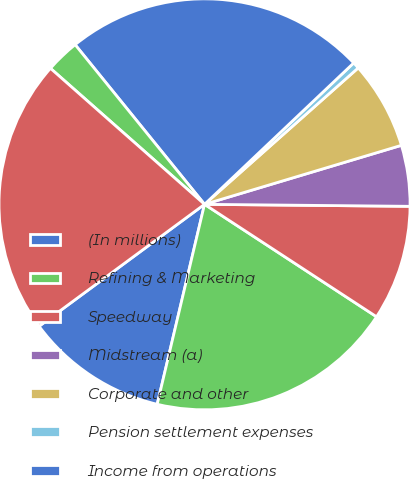Convert chart to OTSL. <chart><loc_0><loc_0><loc_500><loc_500><pie_chart><fcel>(In millions)<fcel>Refining & Marketing<fcel>Speedway<fcel>Midstream (a)<fcel>Corporate and other<fcel>Pension settlement expenses<fcel>Income from operations<fcel>Net interest and other<fcel>Income before income taxes<nl><fcel>11.19%<fcel>19.48%<fcel>9.06%<fcel>4.79%<fcel>6.92%<fcel>0.52%<fcel>23.76%<fcel>2.65%<fcel>21.62%<nl></chart> 